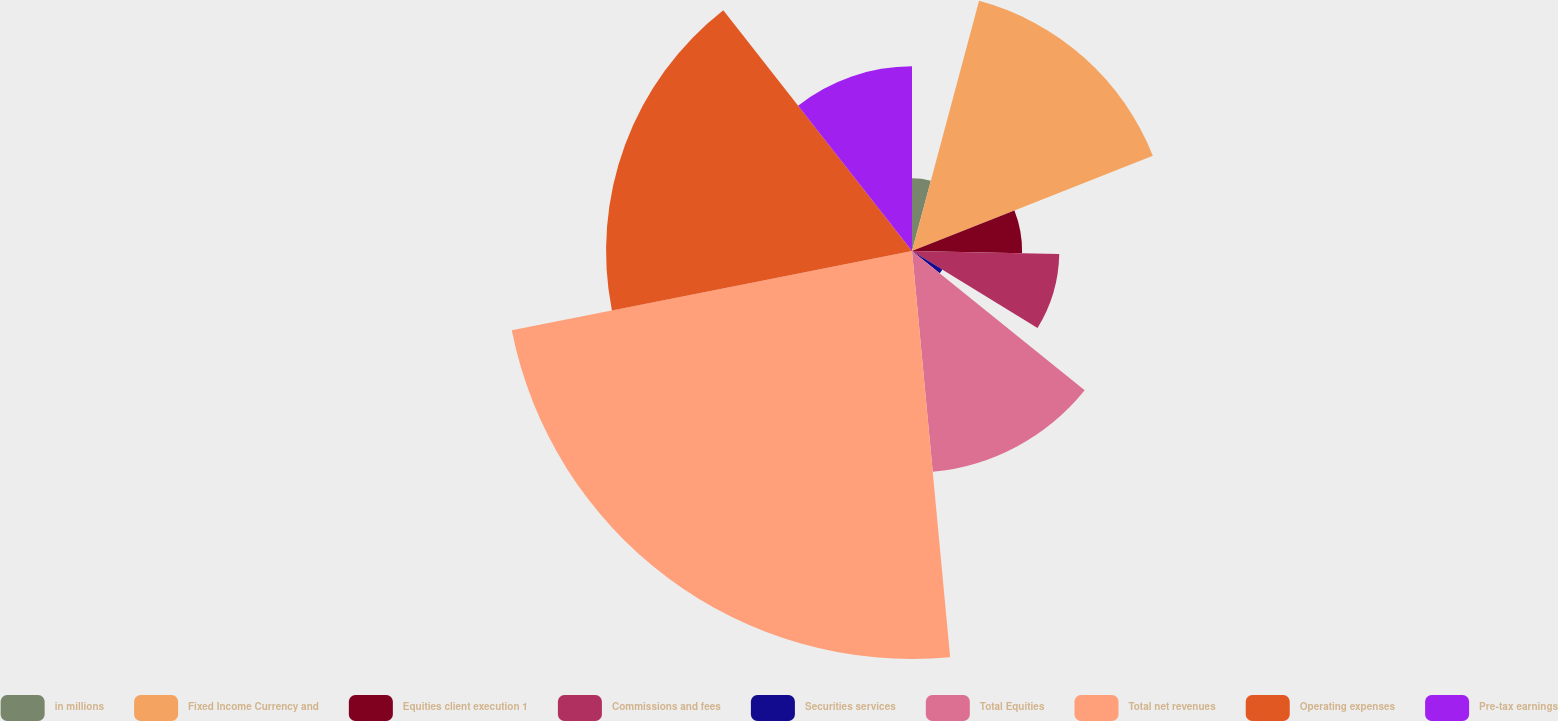<chart> <loc_0><loc_0><loc_500><loc_500><pie_chart><fcel>in millions<fcel>Fixed Income Currency and<fcel>Equities client execution 1<fcel>Commissions and fees<fcel>Securities services<fcel>Total Equities<fcel>Total net revenues<fcel>Operating expenses<fcel>Pre-tax earnings<nl><fcel>4.17%<fcel>14.84%<fcel>6.31%<fcel>8.44%<fcel>2.04%<fcel>12.71%<fcel>23.38%<fcel>17.53%<fcel>10.58%<nl></chart> 